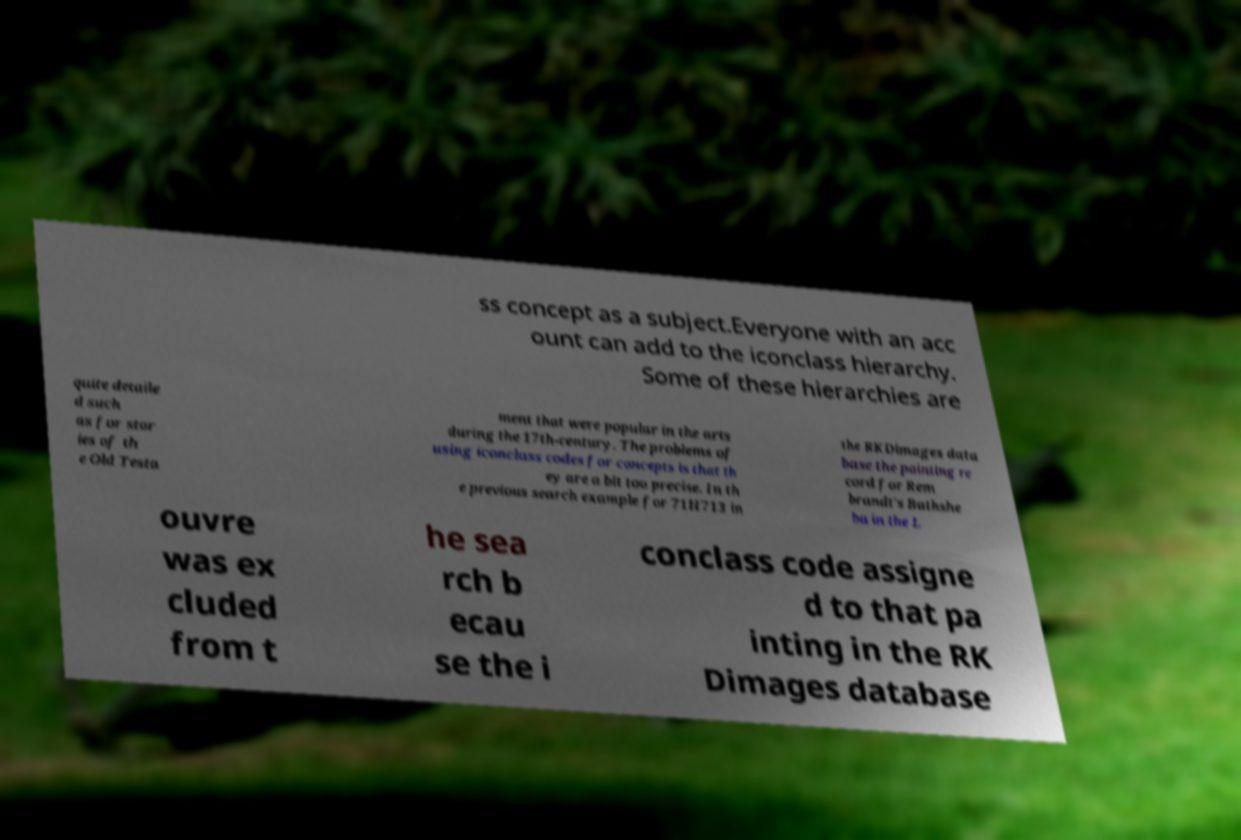There's text embedded in this image that I need extracted. Can you transcribe it verbatim? ss concept as a subject.Everyone with an acc ount can add to the iconclass hierarchy. Some of these hierarchies are quite detaile d such as for stor ies of th e Old Testa ment that were popular in the arts during the 17th-century. The problems of using iconclass codes for concepts is that th ey are a bit too precise. In th e previous search example for 71H713 in the RKDimages data base the painting re cord for Rem brandt's Bathshe ba in the L ouvre was ex cluded from t he sea rch b ecau se the i conclass code assigne d to that pa inting in the RK Dimages database 